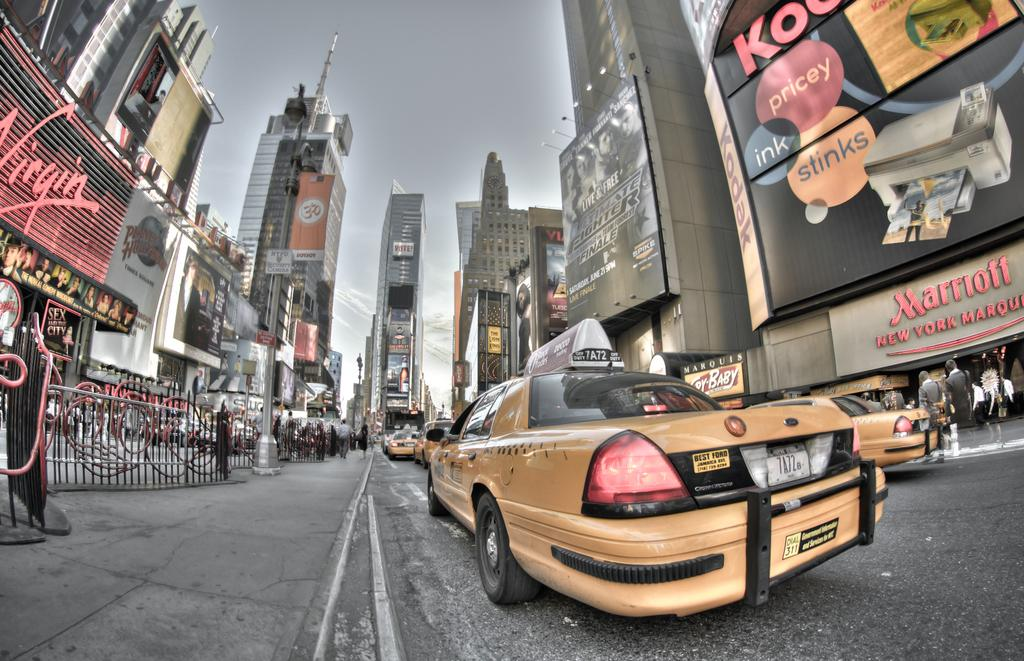<image>
Write a terse but informative summary of the picture. A large Virgin sign can be seen on the left of this treet. 